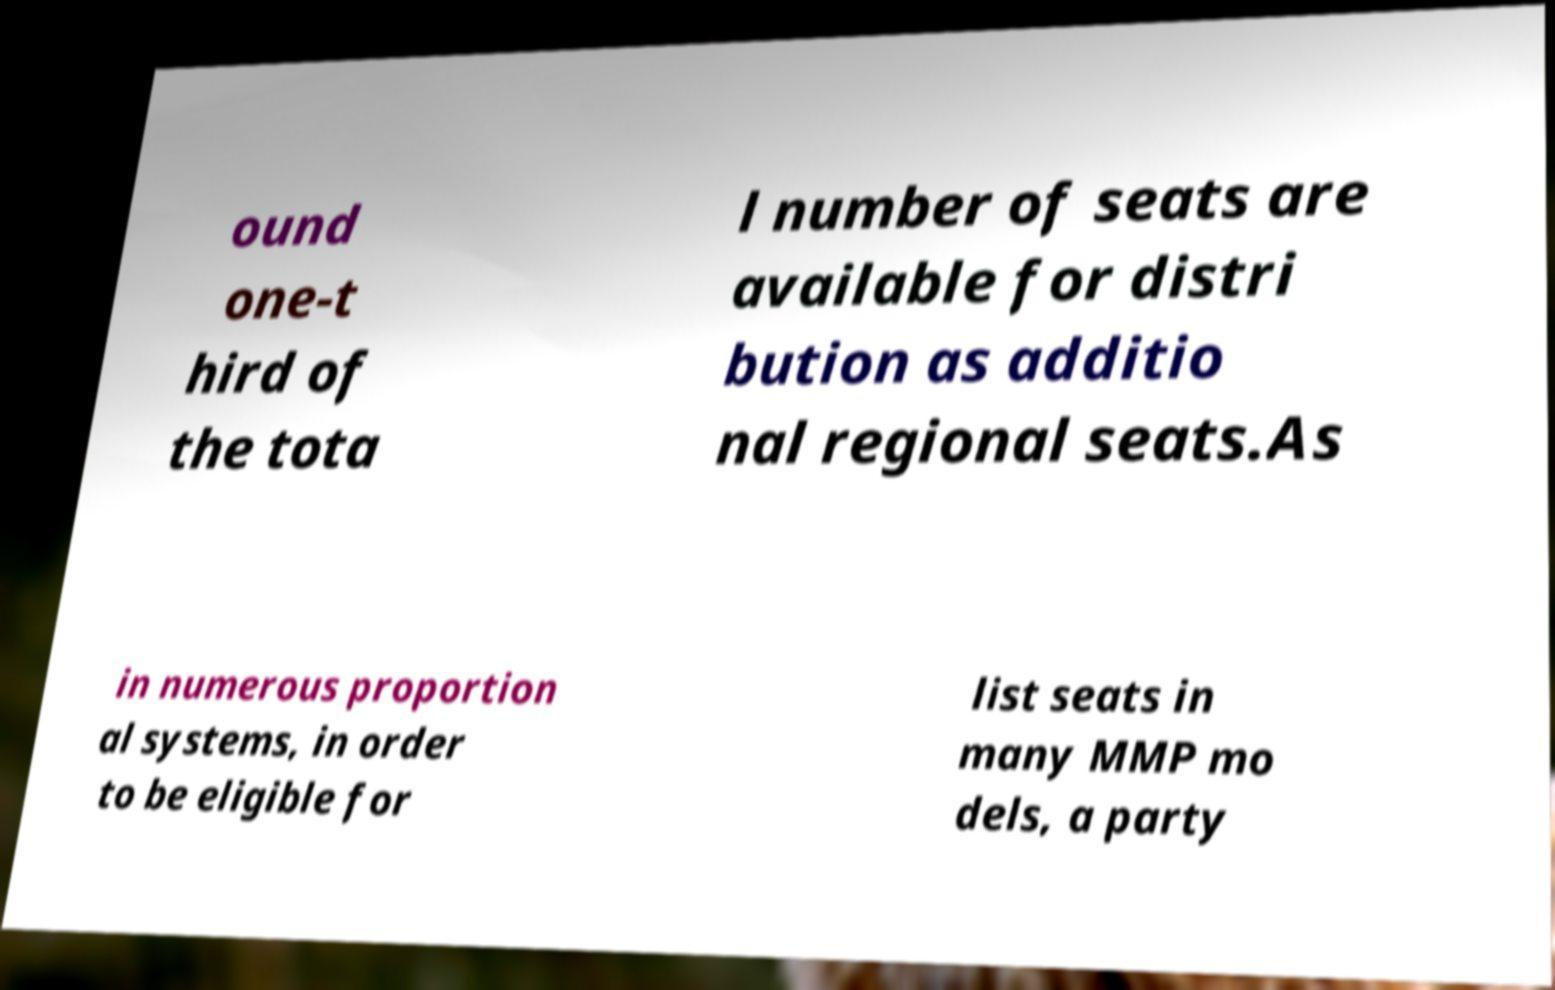Can you read and provide the text displayed in the image?This photo seems to have some interesting text. Can you extract and type it out for me? ound one-t hird of the tota l number of seats are available for distri bution as additio nal regional seats.As in numerous proportion al systems, in order to be eligible for list seats in many MMP mo dels, a party 